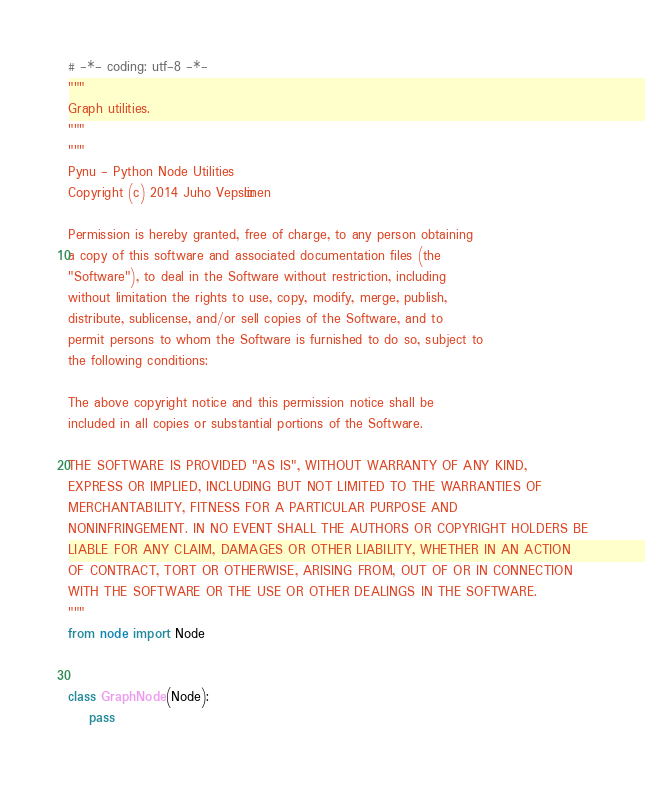Convert code to text. <code><loc_0><loc_0><loc_500><loc_500><_Python_># -*- coding: utf-8 -*-
"""
Graph utilities.
"""
"""
Pynu - Python Node Utilities
Copyright (c) 2014 Juho Vepsäläinen

Permission is hereby granted, free of charge, to any person obtaining
a copy of this software and associated documentation files (the
"Software"), to deal in the Software without restriction, including
without limitation the rights to use, copy, modify, merge, publish,
distribute, sublicense, and/or sell copies of the Software, and to
permit persons to whom the Software is furnished to do so, subject to
the following conditions:

The above copyright notice and this permission notice shall be
included in all copies or substantial portions of the Software.

THE SOFTWARE IS PROVIDED "AS IS", WITHOUT WARRANTY OF ANY KIND,
EXPRESS OR IMPLIED, INCLUDING BUT NOT LIMITED TO THE WARRANTIES OF
MERCHANTABILITY, FITNESS FOR A PARTICULAR PURPOSE AND
NONINFRINGEMENT. IN NO EVENT SHALL THE AUTHORS OR COPYRIGHT HOLDERS BE
LIABLE FOR ANY CLAIM, DAMAGES OR OTHER LIABILITY, WHETHER IN AN ACTION
OF CONTRACT, TORT OR OTHERWISE, ARISING FROM, OUT OF OR IN CONNECTION
WITH THE SOFTWARE OR THE USE OR OTHER DEALINGS IN THE SOFTWARE.
"""
from node import Node


class GraphNode(Node):
    pass
</code> 